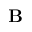Convert formula to latex. <formula><loc_0><loc_0><loc_500><loc_500>{ B }</formula> 